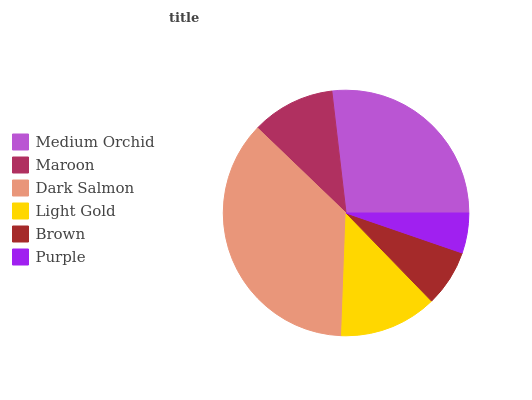Is Purple the minimum?
Answer yes or no. Yes. Is Dark Salmon the maximum?
Answer yes or no. Yes. Is Maroon the minimum?
Answer yes or no. No. Is Maroon the maximum?
Answer yes or no. No. Is Medium Orchid greater than Maroon?
Answer yes or no. Yes. Is Maroon less than Medium Orchid?
Answer yes or no. Yes. Is Maroon greater than Medium Orchid?
Answer yes or no. No. Is Medium Orchid less than Maroon?
Answer yes or no. No. Is Light Gold the high median?
Answer yes or no. Yes. Is Maroon the low median?
Answer yes or no. Yes. Is Purple the high median?
Answer yes or no. No. Is Dark Salmon the low median?
Answer yes or no. No. 